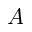Convert formula to latex. <formula><loc_0><loc_0><loc_500><loc_500>A</formula> 